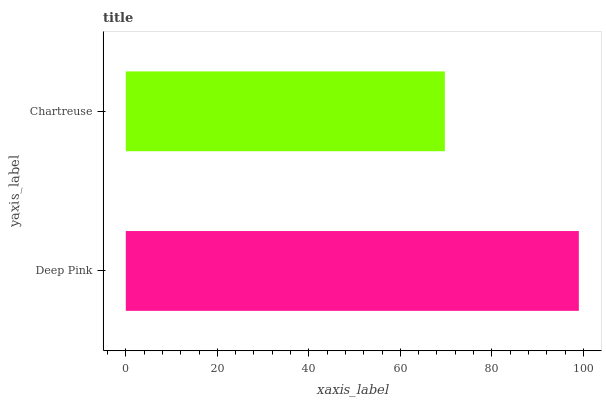Is Chartreuse the minimum?
Answer yes or no. Yes. Is Deep Pink the maximum?
Answer yes or no. Yes. Is Chartreuse the maximum?
Answer yes or no. No. Is Deep Pink greater than Chartreuse?
Answer yes or no. Yes. Is Chartreuse less than Deep Pink?
Answer yes or no. Yes. Is Chartreuse greater than Deep Pink?
Answer yes or no. No. Is Deep Pink less than Chartreuse?
Answer yes or no. No. Is Deep Pink the high median?
Answer yes or no. Yes. Is Chartreuse the low median?
Answer yes or no. Yes. Is Chartreuse the high median?
Answer yes or no. No. Is Deep Pink the low median?
Answer yes or no. No. 